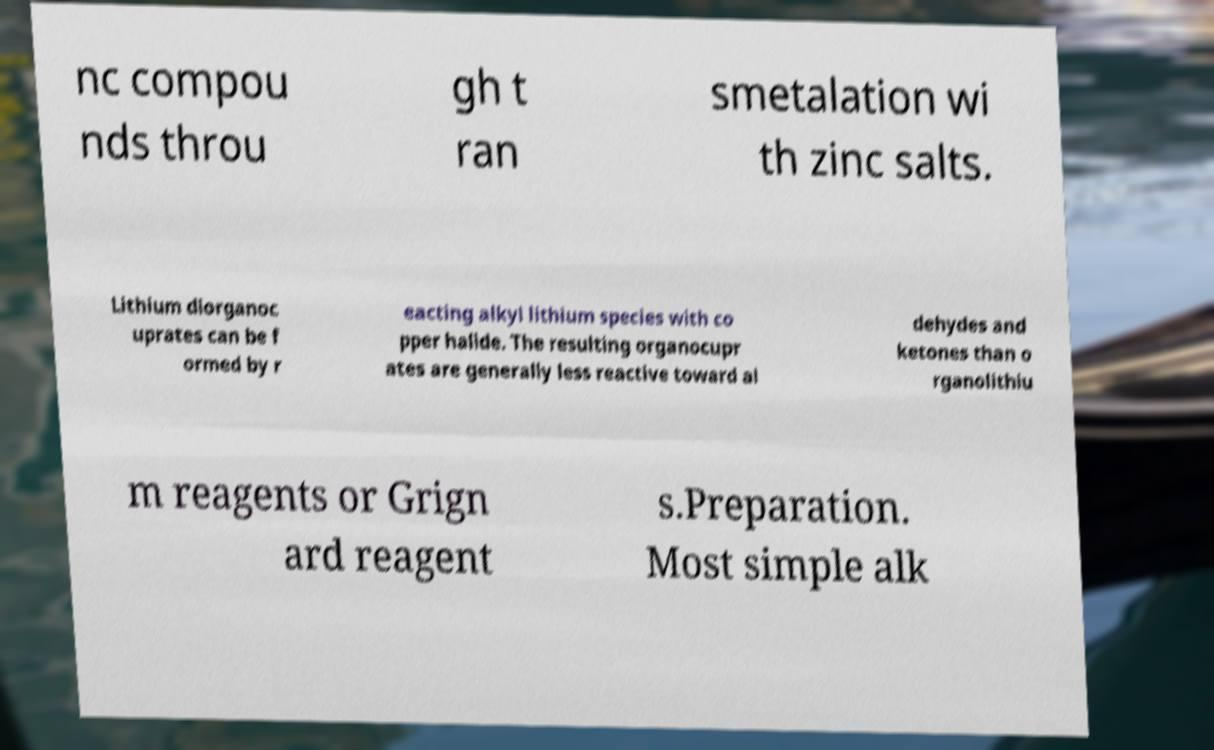Please identify and transcribe the text found in this image. nc compou nds throu gh t ran smetalation wi th zinc salts. Lithium diorganoc uprates can be f ormed by r eacting alkyl lithium species with co pper halide. The resulting organocupr ates are generally less reactive toward al dehydes and ketones than o rganolithiu m reagents or Grign ard reagent s.Preparation. Most simple alk 